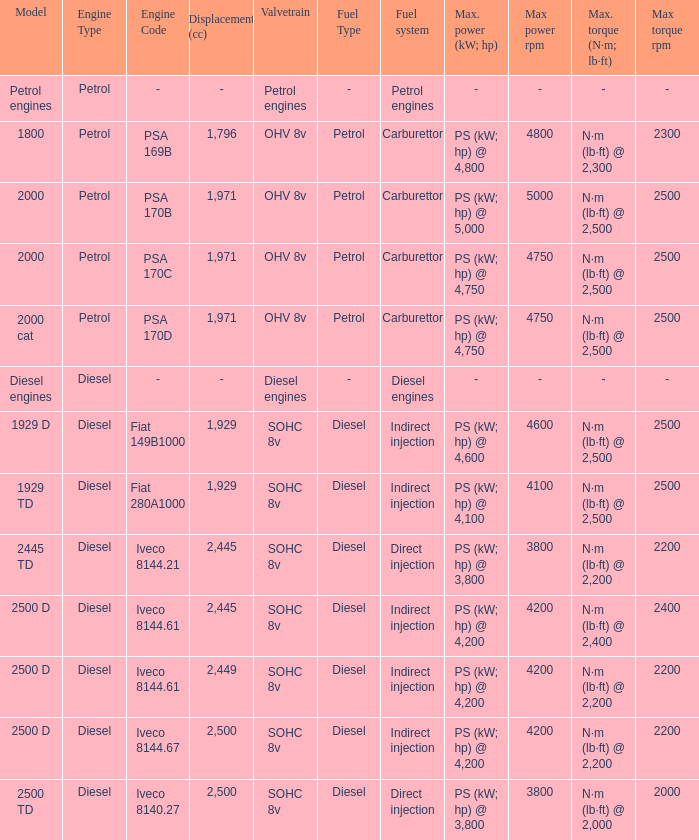For an iveco 8144.61 engine with a 2,445 cc displacement, what is the peak torque capacity? N·m (lb·ft) @ 2,400 rpm. 